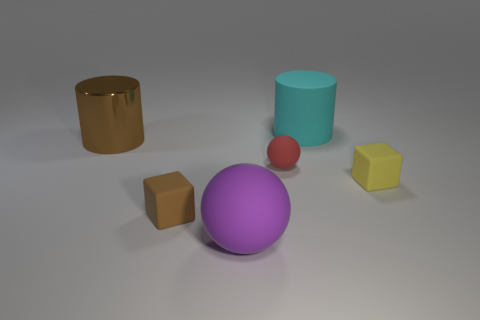Add 4 large matte cylinders. How many objects exist? 10 Subtract all cubes. How many objects are left? 4 Add 5 large blocks. How many large blocks exist? 5 Subtract 0 blue spheres. How many objects are left? 6 Subtract all matte cylinders. Subtract all large blue balls. How many objects are left? 5 Add 1 small yellow objects. How many small yellow objects are left? 2 